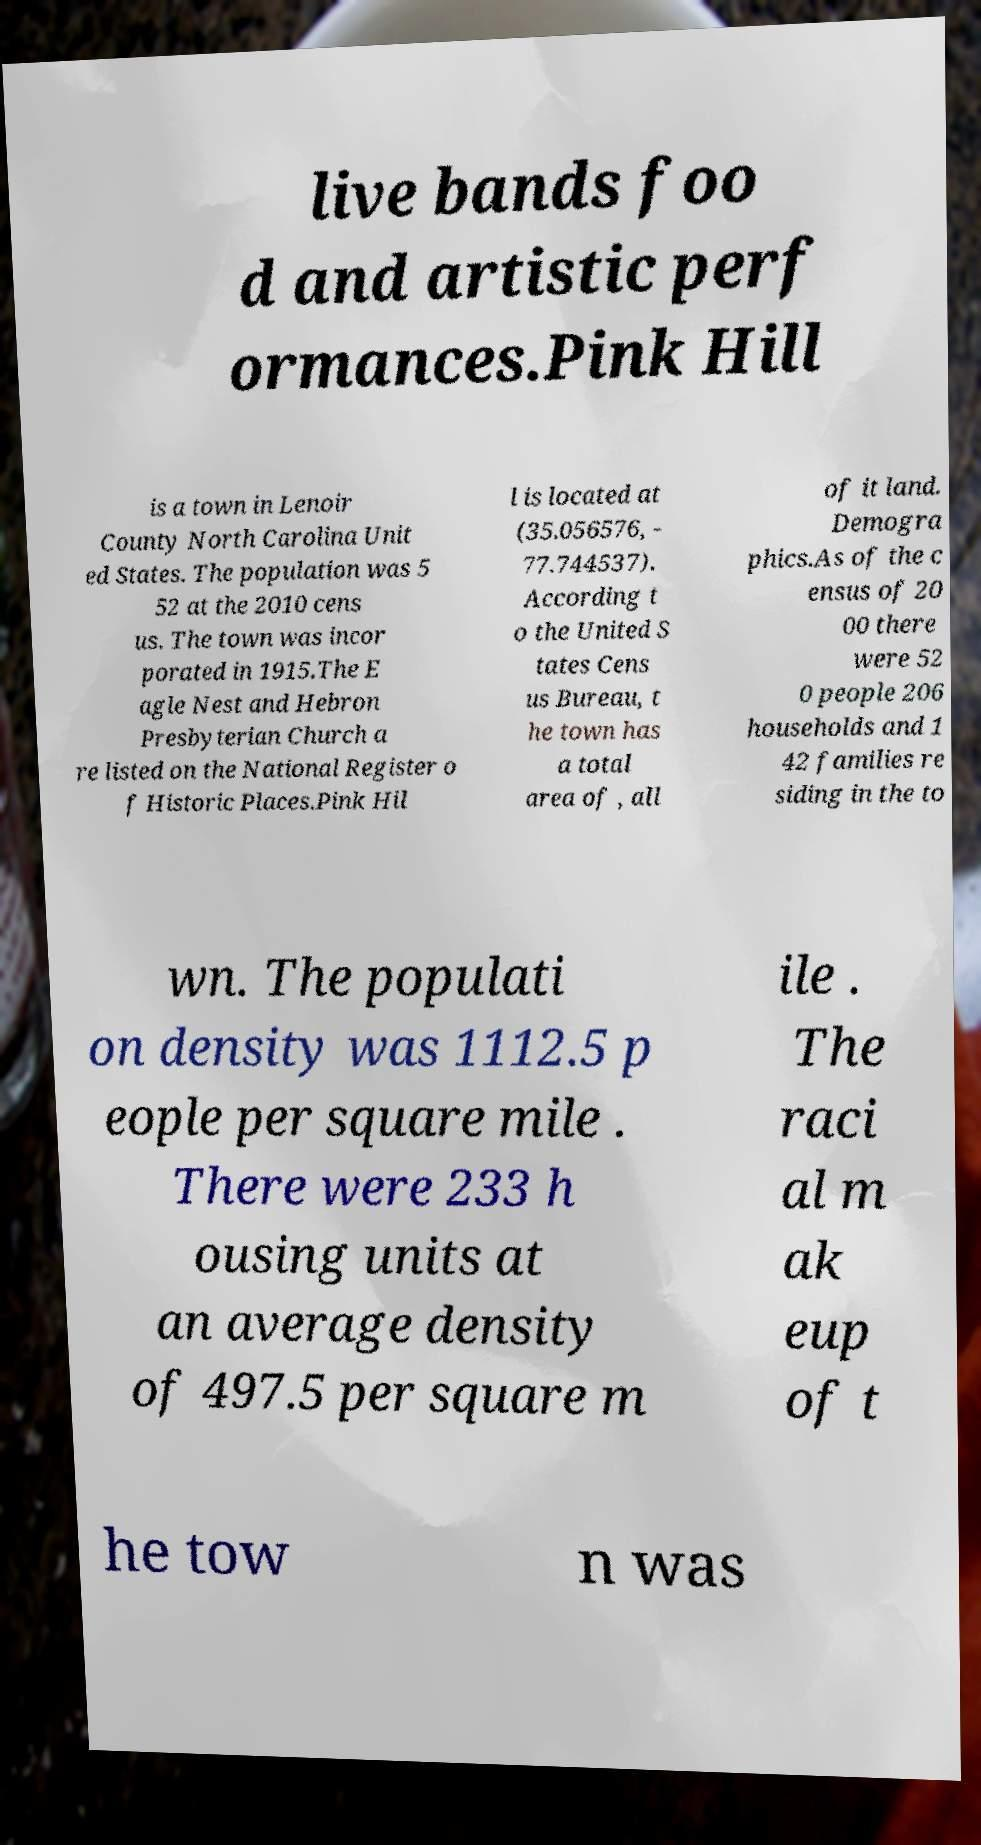Can you accurately transcribe the text from the provided image for me? live bands foo d and artistic perf ormances.Pink Hill is a town in Lenoir County North Carolina Unit ed States. The population was 5 52 at the 2010 cens us. The town was incor porated in 1915.The E agle Nest and Hebron Presbyterian Church a re listed on the National Register o f Historic Places.Pink Hil l is located at (35.056576, - 77.744537). According t o the United S tates Cens us Bureau, t he town has a total area of , all of it land. Demogra phics.As of the c ensus of 20 00 there were 52 0 people 206 households and 1 42 families re siding in the to wn. The populati on density was 1112.5 p eople per square mile . There were 233 h ousing units at an average density of 497.5 per square m ile . The raci al m ak eup of t he tow n was 